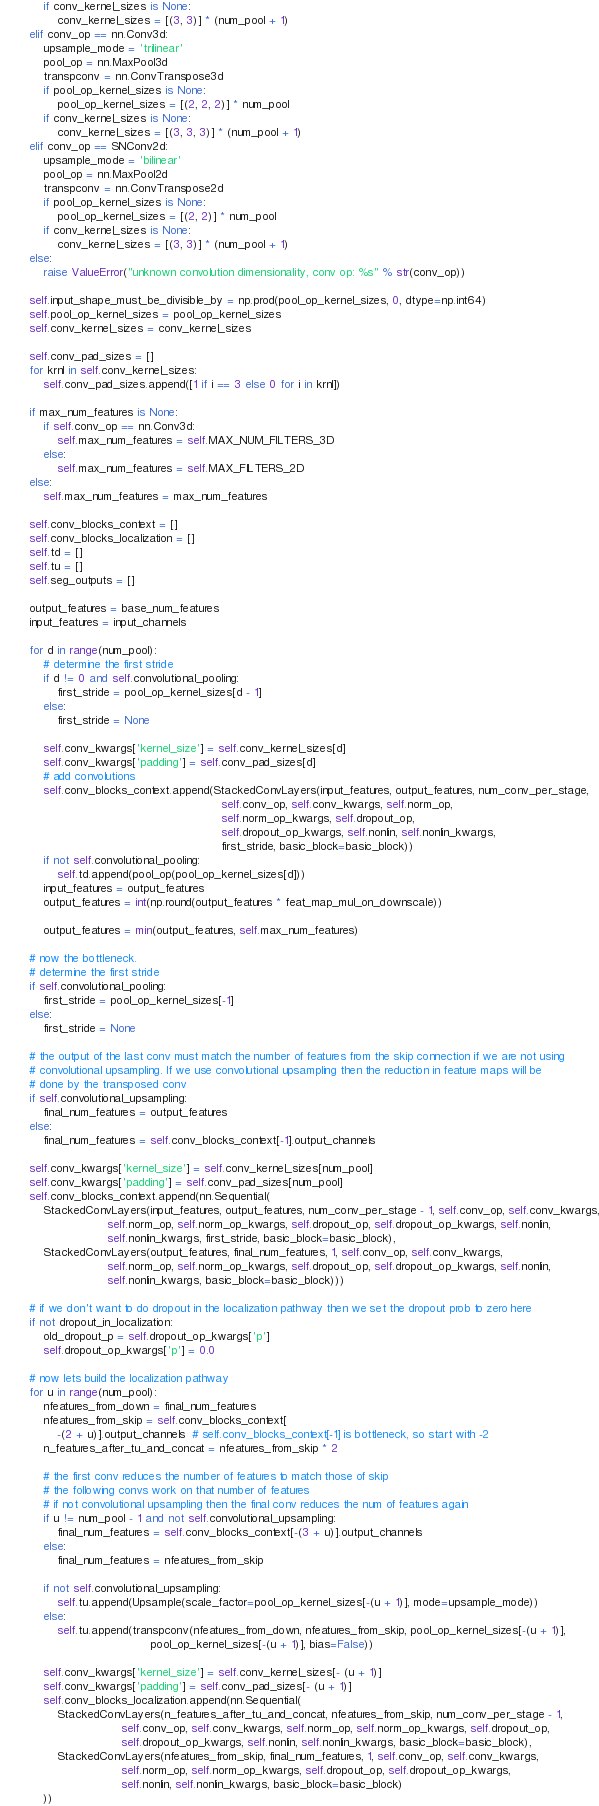Convert code to text. <code><loc_0><loc_0><loc_500><loc_500><_Python_>            if conv_kernel_sizes is None:
                conv_kernel_sizes = [(3, 3)] * (num_pool + 1)
        elif conv_op == nn.Conv3d:
            upsample_mode = 'trilinear'
            pool_op = nn.MaxPool3d
            transpconv = nn.ConvTranspose3d
            if pool_op_kernel_sizes is None:
                pool_op_kernel_sizes = [(2, 2, 2)] * num_pool
            if conv_kernel_sizes is None:
                conv_kernel_sizes = [(3, 3, 3)] * (num_pool + 1)
        elif conv_op == SNConv2d:
            upsample_mode = 'bilinear'
            pool_op = nn.MaxPool2d
            transpconv = nn.ConvTranspose2d
            if pool_op_kernel_sizes is None:
                pool_op_kernel_sizes = [(2, 2)] * num_pool
            if conv_kernel_sizes is None:
                conv_kernel_sizes = [(3, 3)] * (num_pool + 1)
        else:
            raise ValueError("unknown convolution dimensionality, conv op: %s" % str(conv_op))

        self.input_shape_must_be_divisible_by = np.prod(pool_op_kernel_sizes, 0, dtype=np.int64)
        self.pool_op_kernel_sizes = pool_op_kernel_sizes
        self.conv_kernel_sizes = conv_kernel_sizes

        self.conv_pad_sizes = []
        for krnl in self.conv_kernel_sizes:
            self.conv_pad_sizes.append([1 if i == 3 else 0 for i in krnl])

        if max_num_features is None:
            if self.conv_op == nn.Conv3d:
                self.max_num_features = self.MAX_NUM_FILTERS_3D
            else:
                self.max_num_features = self.MAX_FILTERS_2D
        else:
            self.max_num_features = max_num_features

        self.conv_blocks_context = []
        self.conv_blocks_localization = []
        self.td = []
        self.tu = []
        self.seg_outputs = []

        output_features = base_num_features
        input_features = input_channels

        for d in range(num_pool):
            # determine the first stride
            if d != 0 and self.convolutional_pooling:
                first_stride = pool_op_kernel_sizes[d - 1]
            else:
                first_stride = None

            self.conv_kwargs['kernel_size'] = self.conv_kernel_sizes[d]
            self.conv_kwargs['padding'] = self.conv_pad_sizes[d]
            # add convolutions
            self.conv_blocks_context.append(StackedConvLayers(input_features, output_features, num_conv_per_stage,
                                                              self.conv_op, self.conv_kwargs, self.norm_op,
                                                              self.norm_op_kwargs, self.dropout_op,
                                                              self.dropout_op_kwargs, self.nonlin, self.nonlin_kwargs,
                                                              first_stride, basic_block=basic_block))
            if not self.convolutional_pooling:
                self.td.append(pool_op(pool_op_kernel_sizes[d]))
            input_features = output_features
            output_features = int(np.round(output_features * feat_map_mul_on_downscale))

            output_features = min(output_features, self.max_num_features)

        # now the bottleneck.
        # determine the first stride
        if self.convolutional_pooling:
            first_stride = pool_op_kernel_sizes[-1]
        else:
            first_stride = None

        # the output of the last conv must match the number of features from the skip connection if we are not using
        # convolutional upsampling. If we use convolutional upsampling then the reduction in feature maps will be
        # done by the transposed conv
        if self.convolutional_upsampling:
            final_num_features = output_features
        else:
            final_num_features = self.conv_blocks_context[-1].output_channels

        self.conv_kwargs['kernel_size'] = self.conv_kernel_sizes[num_pool]
        self.conv_kwargs['padding'] = self.conv_pad_sizes[num_pool]
        self.conv_blocks_context.append(nn.Sequential(
            StackedConvLayers(input_features, output_features, num_conv_per_stage - 1, self.conv_op, self.conv_kwargs,
                              self.norm_op, self.norm_op_kwargs, self.dropout_op, self.dropout_op_kwargs, self.nonlin,
                              self.nonlin_kwargs, first_stride, basic_block=basic_block),
            StackedConvLayers(output_features, final_num_features, 1, self.conv_op, self.conv_kwargs,
                              self.norm_op, self.norm_op_kwargs, self.dropout_op, self.dropout_op_kwargs, self.nonlin,
                              self.nonlin_kwargs, basic_block=basic_block)))

        # if we don't want to do dropout in the localization pathway then we set the dropout prob to zero here
        if not dropout_in_localization:
            old_dropout_p = self.dropout_op_kwargs['p']
            self.dropout_op_kwargs['p'] = 0.0

        # now lets build the localization pathway
        for u in range(num_pool):
            nfeatures_from_down = final_num_features
            nfeatures_from_skip = self.conv_blocks_context[
                -(2 + u)].output_channels  # self.conv_blocks_context[-1] is bottleneck, so start with -2
            n_features_after_tu_and_concat = nfeatures_from_skip * 2

            # the first conv reduces the number of features to match those of skip
            # the following convs work on that number of features
            # if not convolutional upsampling then the final conv reduces the num of features again
            if u != num_pool - 1 and not self.convolutional_upsampling:
                final_num_features = self.conv_blocks_context[-(3 + u)].output_channels
            else:
                final_num_features = nfeatures_from_skip

            if not self.convolutional_upsampling:
                self.tu.append(Upsample(scale_factor=pool_op_kernel_sizes[-(u + 1)], mode=upsample_mode))
            else:
                self.tu.append(transpconv(nfeatures_from_down, nfeatures_from_skip, pool_op_kernel_sizes[-(u + 1)],
                                          pool_op_kernel_sizes[-(u + 1)], bias=False))

            self.conv_kwargs['kernel_size'] = self.conv_kernel_sizes[- (u + 1)]
            self.conv_kwargs['padding'] = self.conv_pad_sizes[- (u + 1)]
            self.conv_blocks_localization.append(nn.Sequential(
                StackedConvLayers(n_features_after_tu_and_concat, nfeatures_from_skip, num_conv_per_stage - 1,
                                  self.conv_op, self.conv_kwargs, self.norm_op, self.norm_op_kwargs, self.dropout_op,
                                  self.dropout_op_kwargs, self.nonlin, self.nonlin_kwargs, basic_block=basic_block),
                StackedConvLayers(nfeatures_from_skip, final_num_features, 1, self.conv_op, self.conv_kwargs,
                                  self.norm_op, self.norm_op_kwargs, self.dropout_op, self.dropout_op_kwargs,
                                  self.nonlin, self.nonlin_kwargs, basic_block=basic_block)
            ))
</code> 